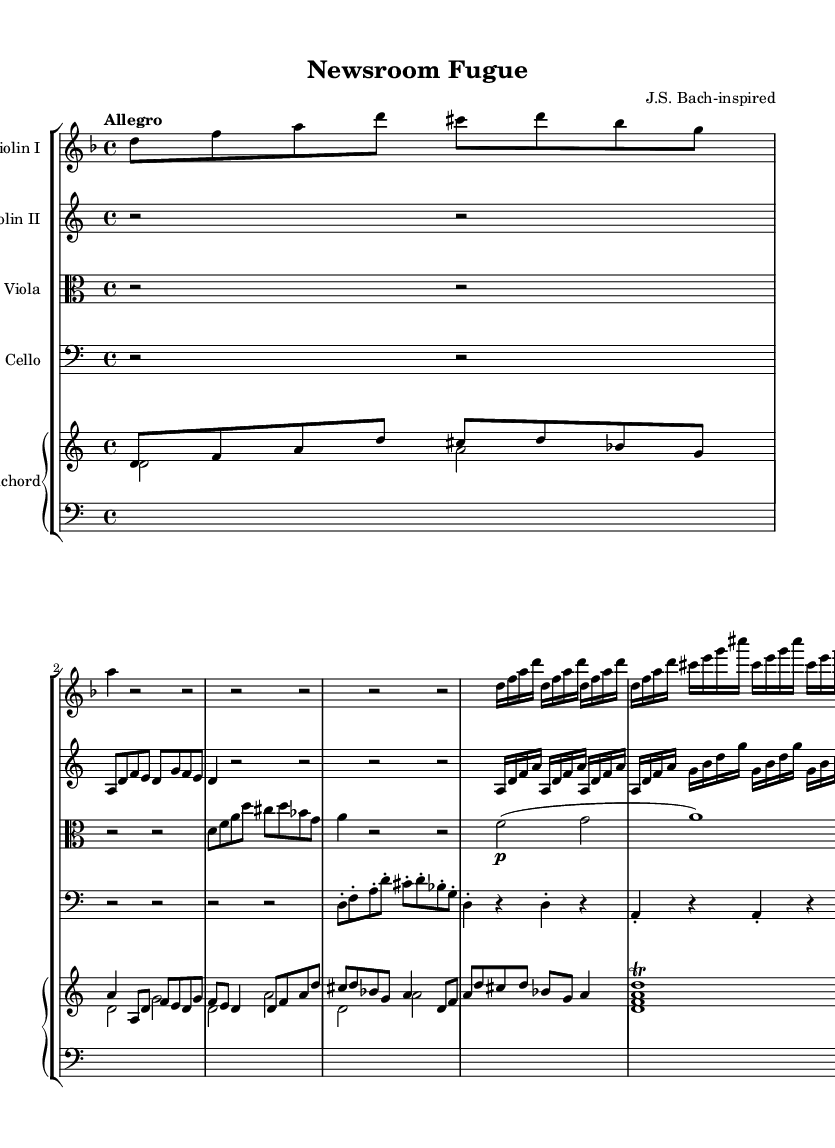What is the key signature of this music? The key signature is indicated by the sharps or flats at the beginning of the staff. In this piece, there is one flat (B♭), which means the key is D minor.
Answer: D minor What is the time signature of this music? The time signature is represented at the beginning of the staff, showing how many beats are in each measure. Here, the time signature is 4/4, indicating four beats per measure.
Answer: 4/4 What is the tempo marking of this music? The tempo is specified at the beginning of the score and describes how fast the piece should be played. The marking is "Allegro," indicating a fast tempo.
Answer: Allegro What instruments are featured in this orchestral piece? The instruments can be identified by the labels at the beginning of each staff. In this piece, the instruments are Violin I, Violin II, Viola, Cello, and Harpsichord.
Answer: Violin I, Violin II, Viola, Cello, Harpsichord How many measures are there in the excerpt? By counting the vertical lines (bar lines) which separate each measure in the piece, we find that there are a total of 16 measures in this excerpt.
Answer: 16 What compositional technique is used prominently in this piece? The repeated patterns in the music, particularly noticeable in the violin parts, suggest the use of a fugue, which is a common technique in Baroque music where melodies are interwoven.
Answer: Fugue What unique feature does the harpsichord part include? The harpsichord notation includes trills, which are indicated by the markings next to the chords, creating a characteristic flourish common in Baroque compositions.
Answer: Trills 